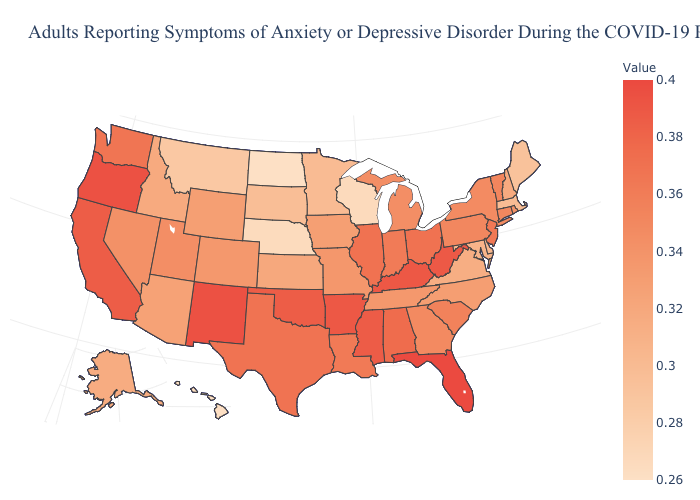Does North Dakota have the lowest value in the USA?
Concise answer only. Yes. Does Hawaii have the lowest value in the West?
Answer briefly. Yes. Does North Dakota have the lowest value in the USA?
Quick response, please. Yes. 